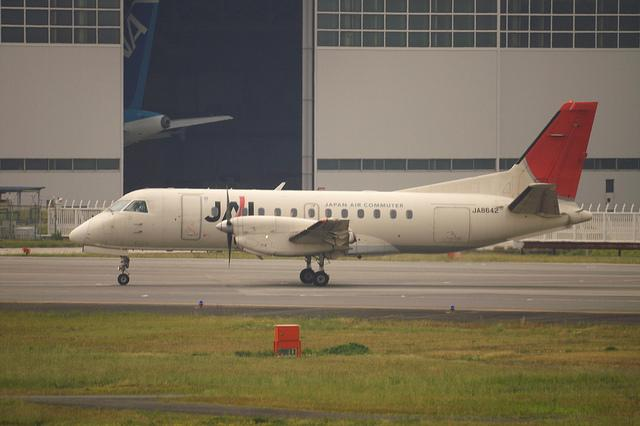What color is the tip of the tailfin on the Japanese propeller plane? Please explain your reasoning. red. It shows a color that's similar to those cups used in beer pong. 